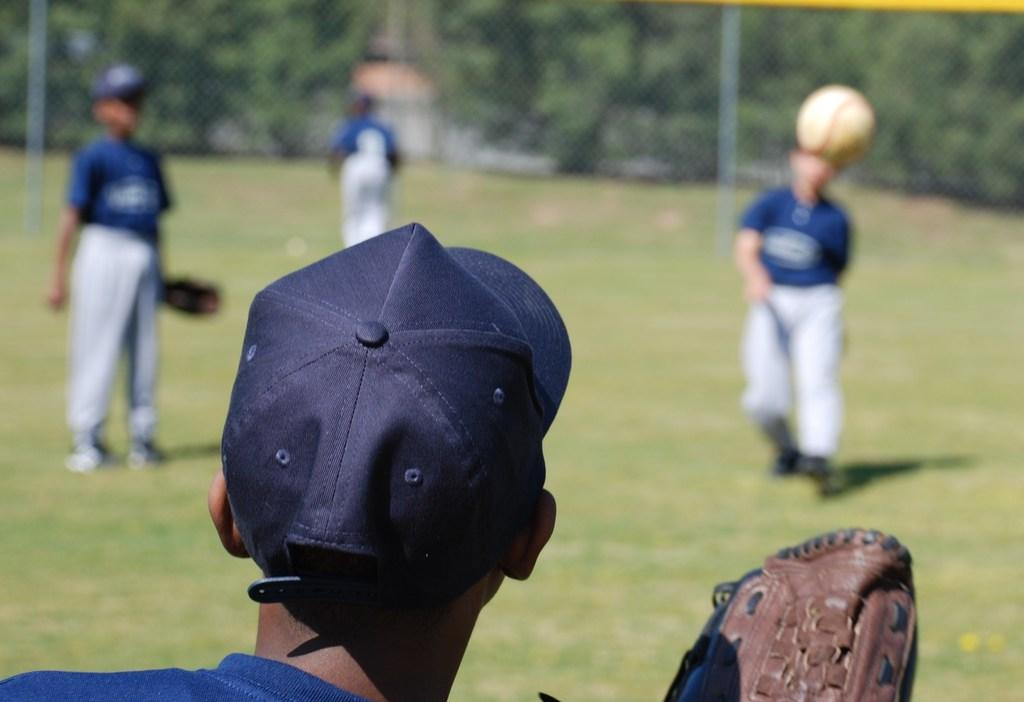How many people are present in the image? There are four persons in the image. What object can be seen in the image besides the people? There is a ball in the image. What can be seen in the background of the image? There are trees in the background of the image. What type of behavioral theory can be observed in the image? There is no behavioral theory present in the image; it features four persons and a ball. Can you hear any cries in the image? There is no auditory information in the image, as it is a static visual representation. 